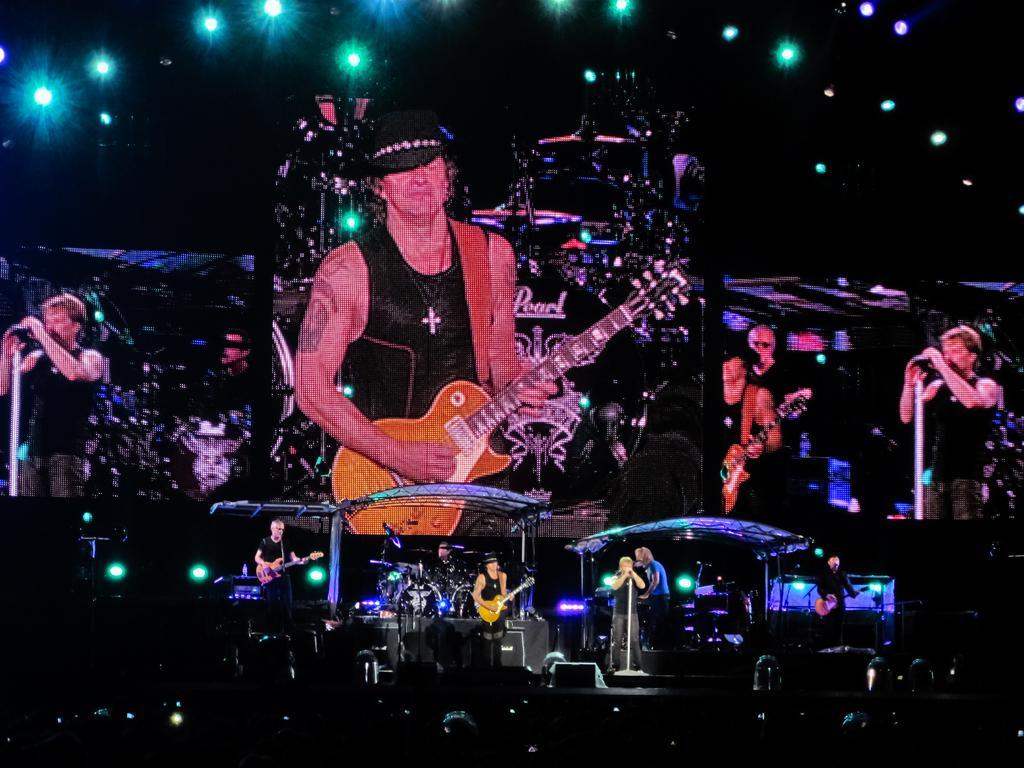Can you describe this image briefly? In this image we can see group of people, in the middle of the image few people are playing guitar in front of microphone, in the background we can see projection of people and lights. 